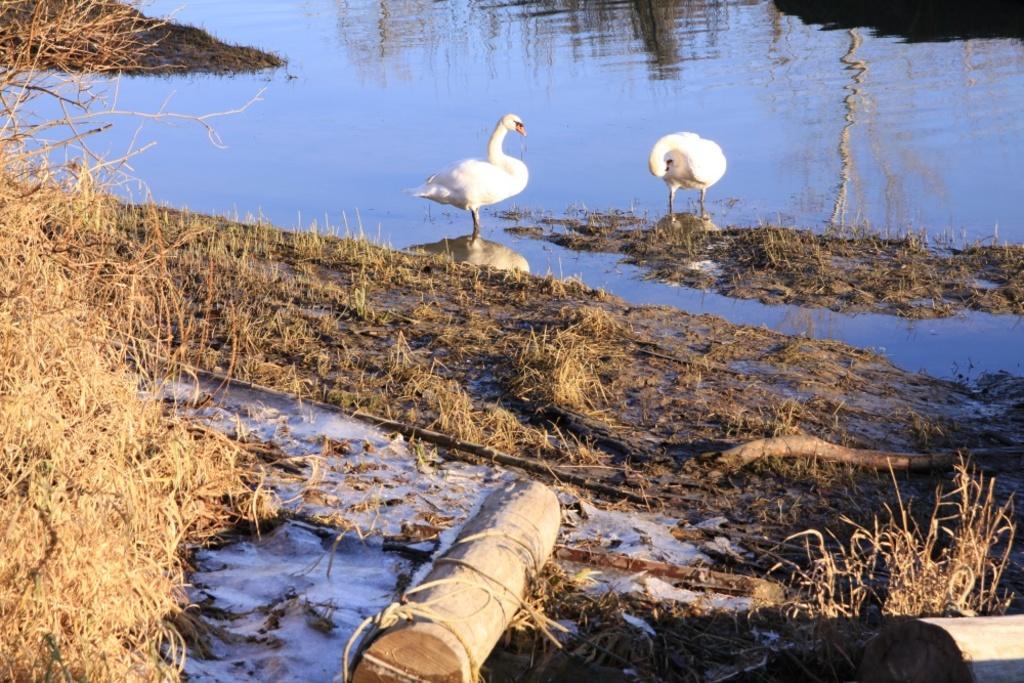How would you summarize this image in a sentence or two? This is an outside view. In this image I can see the water and two white color birds are standing on the rocks. At the bottom of the image I can see the grass and some sticks. 